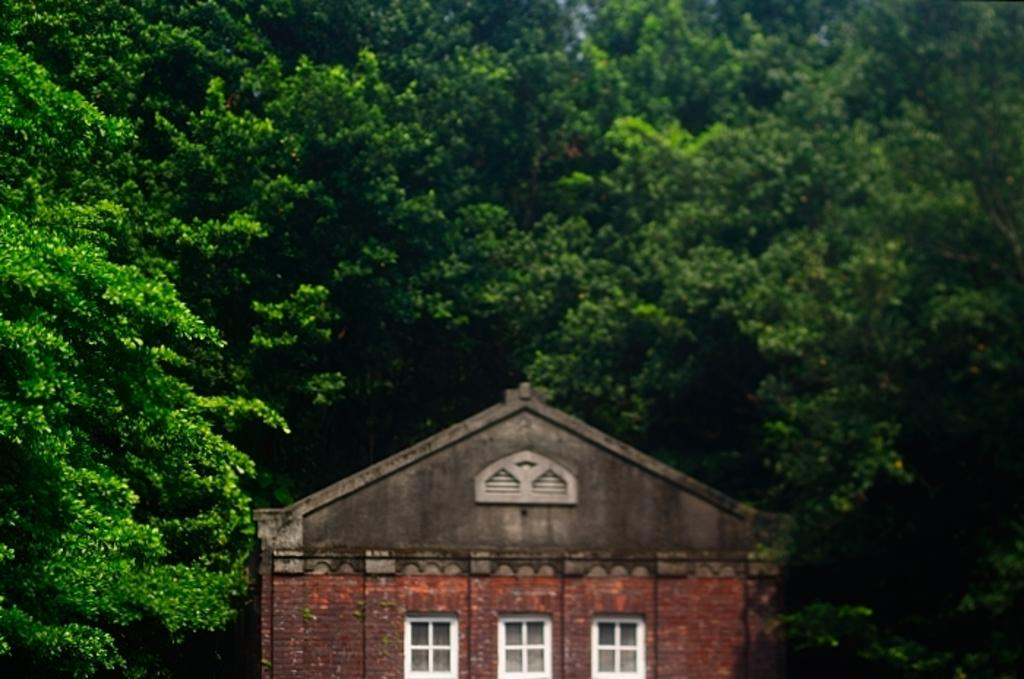What type of structure is visible in the image? There is a house in the image. What feature can be seen on the house? The house has windows. What can be seen in the background of the image? There are trees in the background of the image. How many frogs are sitting on the orange worm in the image? There are no frogs or worms present in the image; it features a house with windows and trees in the background. 